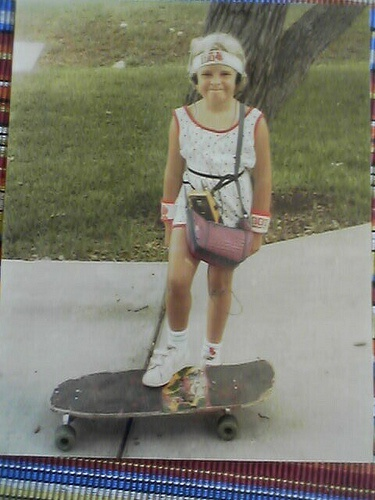Describe the objects in this image and their specific colors. I can see people in blue, darkgray, gray, and tan tones, skateboard in blue, gray, darkgray, and black tones, and handbag in blue, gray, and black tones in this image. 